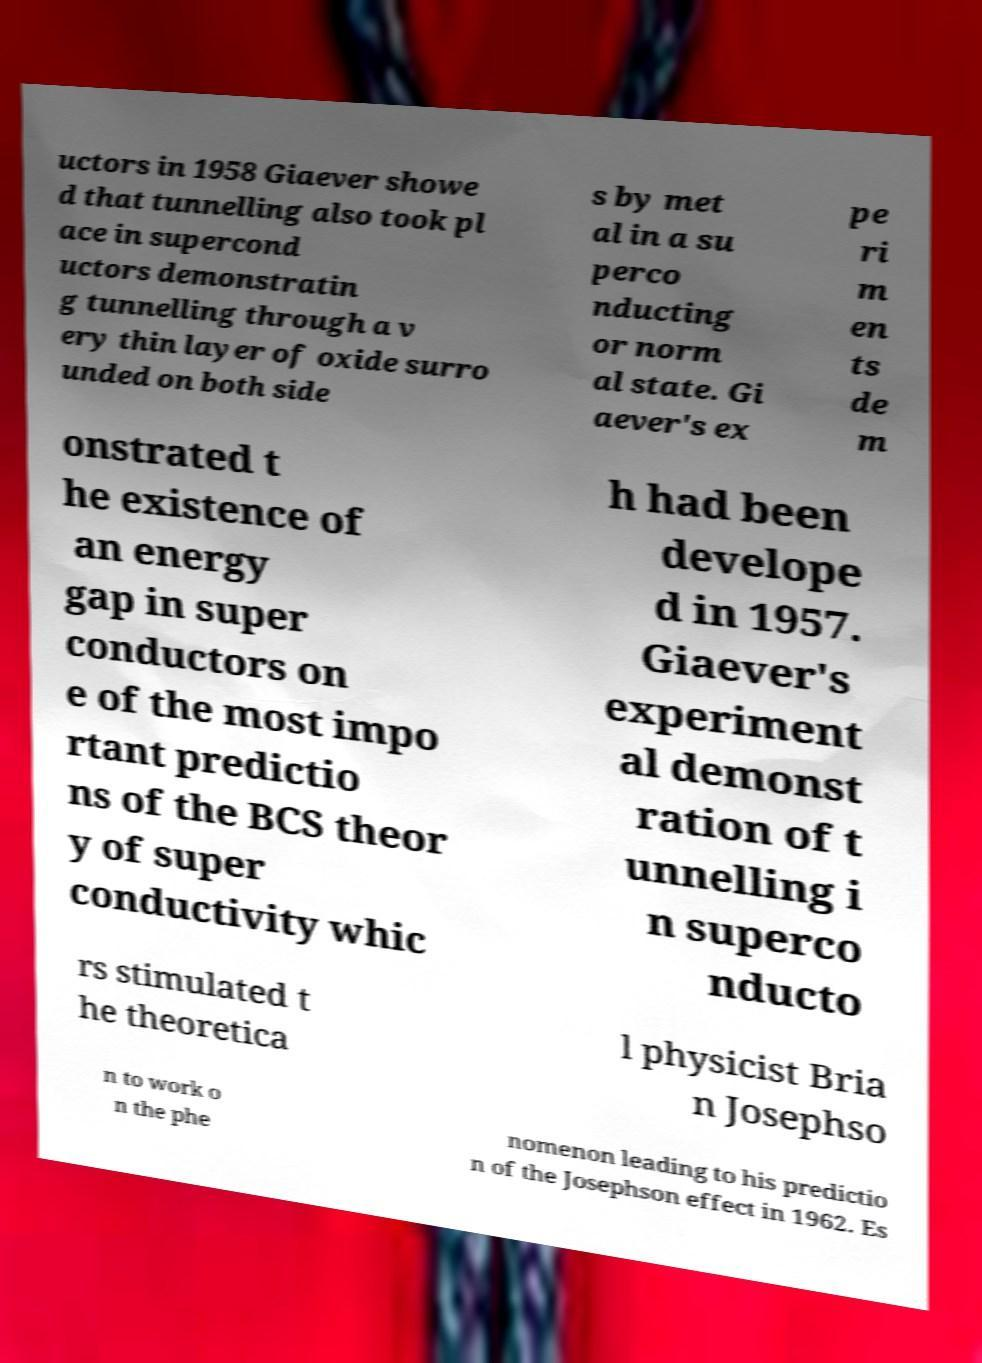Could you assist in decoding the text presented in this image and type it out clearly? uctors in 1958 Giaever showe d that tunnelling also took pl ace in supercond uctors demonstratin g tunnelling through a v ery thin layer of oxide surro unded on both side s by met al in a su perco nducting or norm al state. Gi aever's ex pe ri m en ts de m onstrated t he existence of an energy gap in super conductors on e of the most impo rtant predictio ns of the BCS theor y of super conductivity whic h had been develope d in 1957. Giaever's experiment al demonst ration of t unnelling i n superco nducto rs stimulated t he theoretica l physicist Bria n Josephso n to work o n the phe nomenon leading to his predictio n of the Josephson effect in 1962. Es 